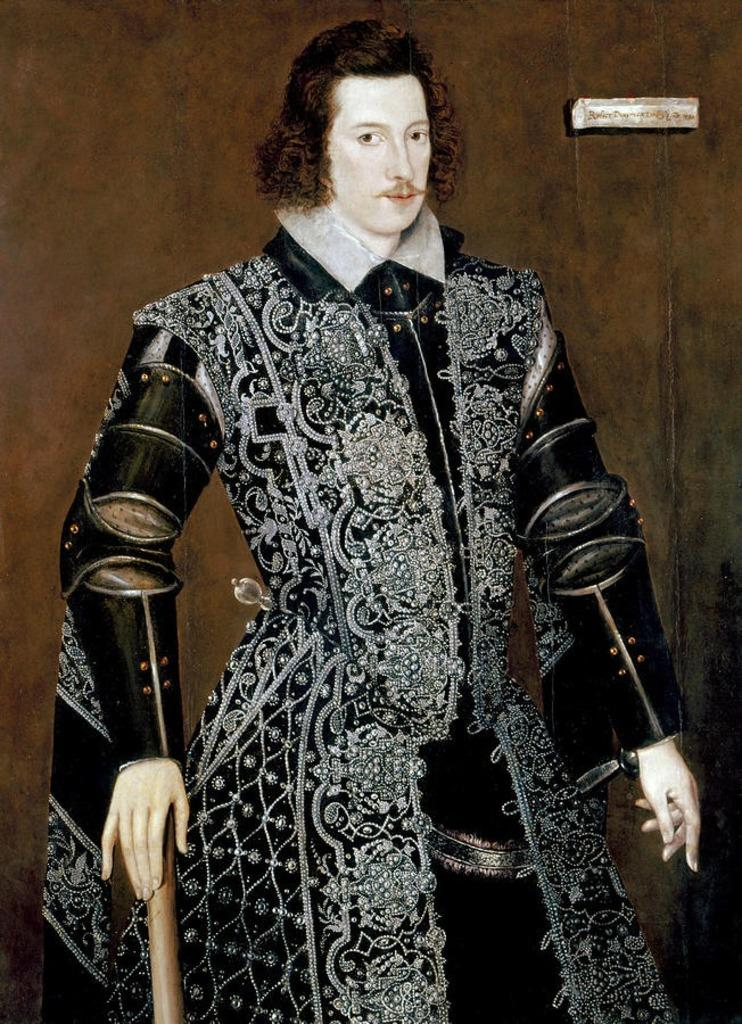What isting is the main subject of the painting in the image? The main subject of the painting in the image is a man. What is the man wearing in the painting? The man is wearing a black dress in the painting. What color is the wall in the background of the painting? The wall in the background of the painting is brown-colored. What type of authority does the man in the painting hold? The image does not provide any information about the man's authority or position, as it only shows a painting of a man wearing a black dress with a brown-colored wall in the background. 